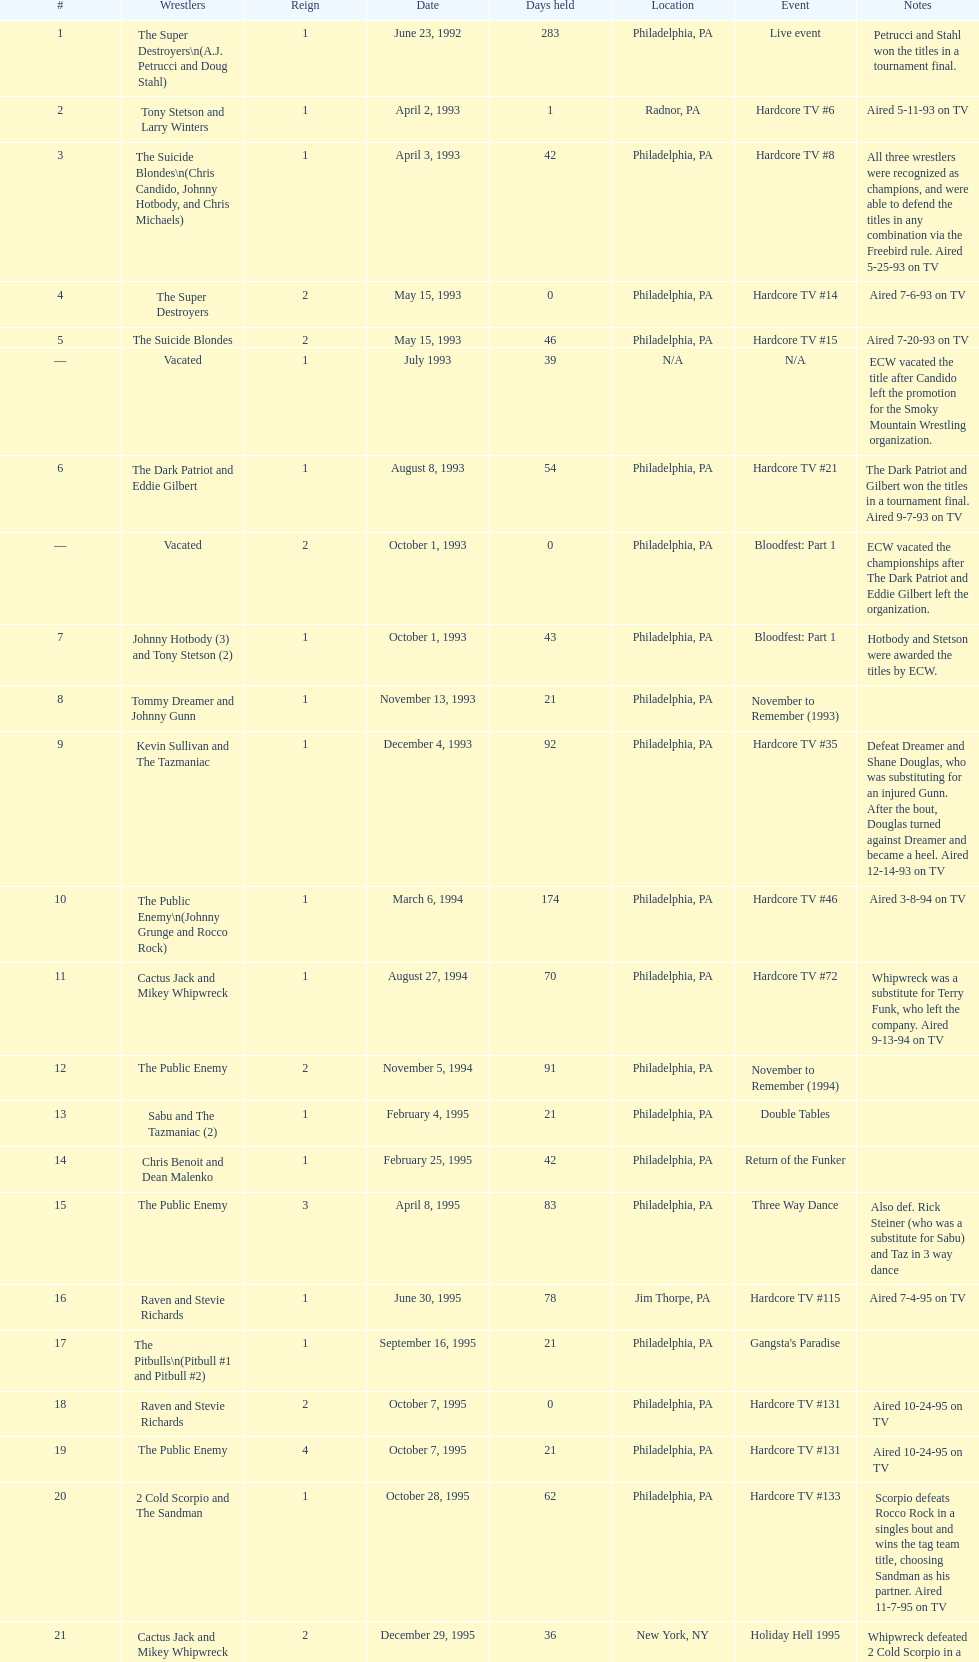Who maintained the title the greatest number of times, the super destroyers or the dudley boyz? The Dudley Boyz. 